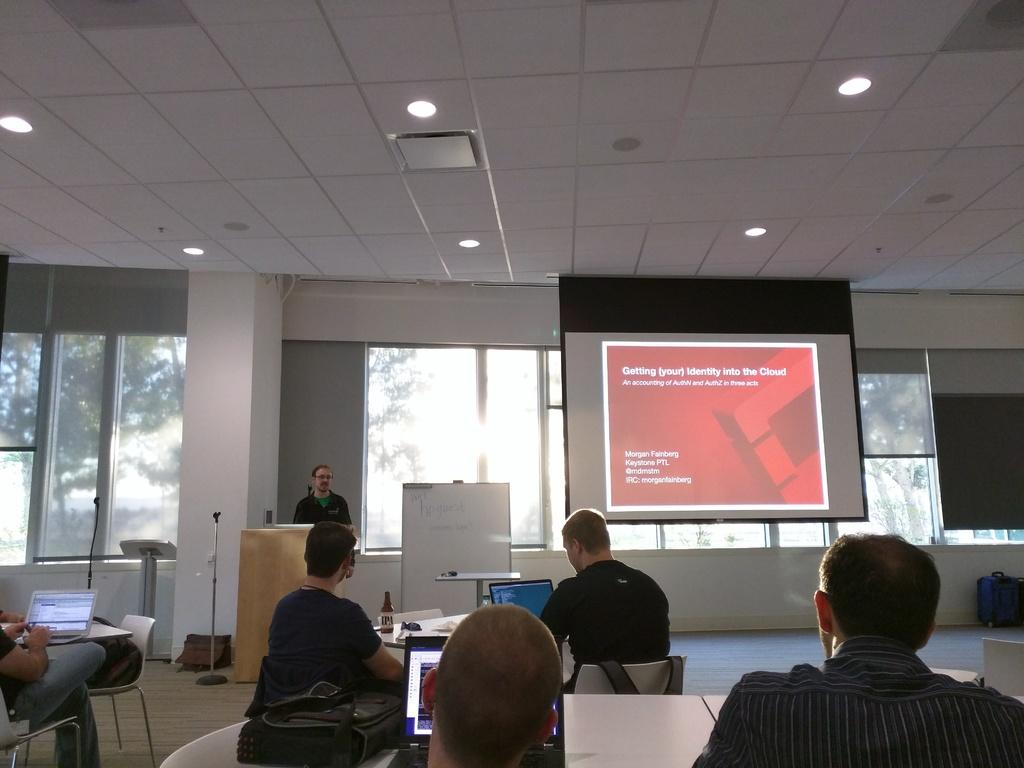What type of structure can be seen in the image? There is a wall in the image. What feature allows light and air into the space? There is a window in the image. What is the uppermost part of the structure? There is a roof in the image. What is present on the wall in the image? There is a screen in the image. What are the people in the image doing? There are people sitting on chairs in the image. What furniture is visible in the image? There is a table in the image. What electronic device is on the table? There is a laptop on the table. What else is on the table besides the laptop? There is a bottle and papers on the table. What type of animal can be seen interacting with the laptop in the image? There are no animals present in the image; it features people sitting on chairs and using a laptop. What historical event is being discussed in the image? There is no indication of any historical event being discussed in the image. 